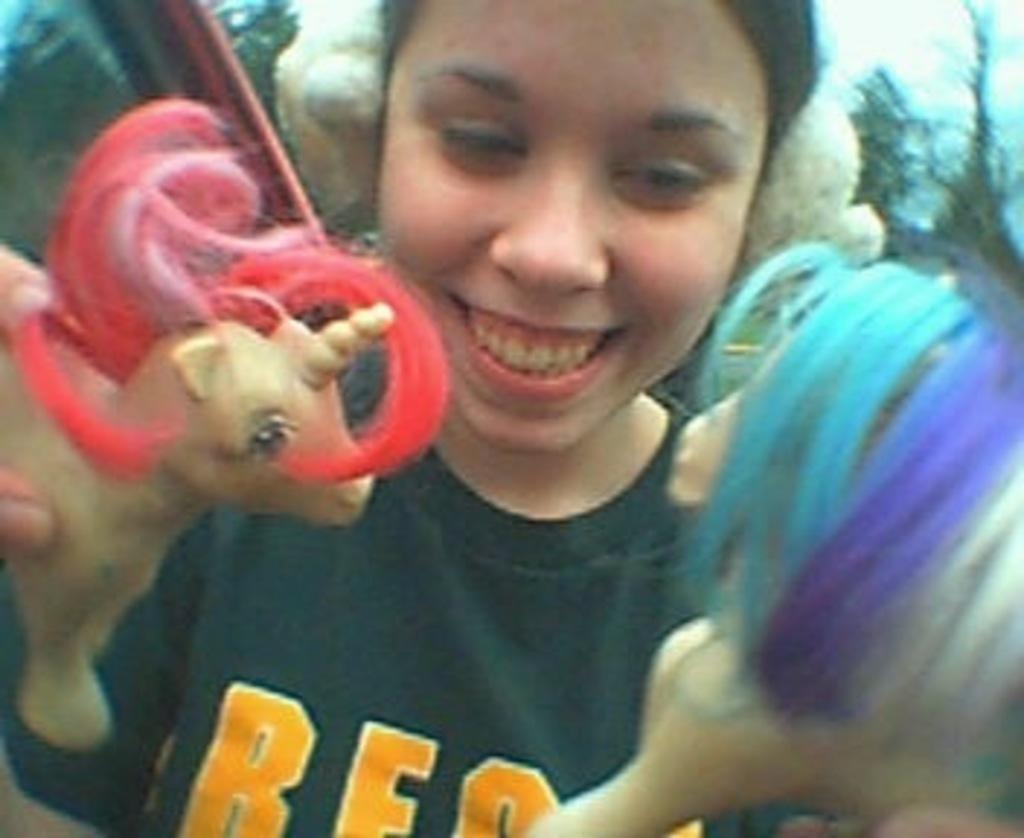Who is the main subject in the image? There is a woman in the image. What is the woman doing in the image? The woman is playing with toy horses. What is the price of the balloon in the image? There is no balloon present in the image, so it is not possible to determine its price. 